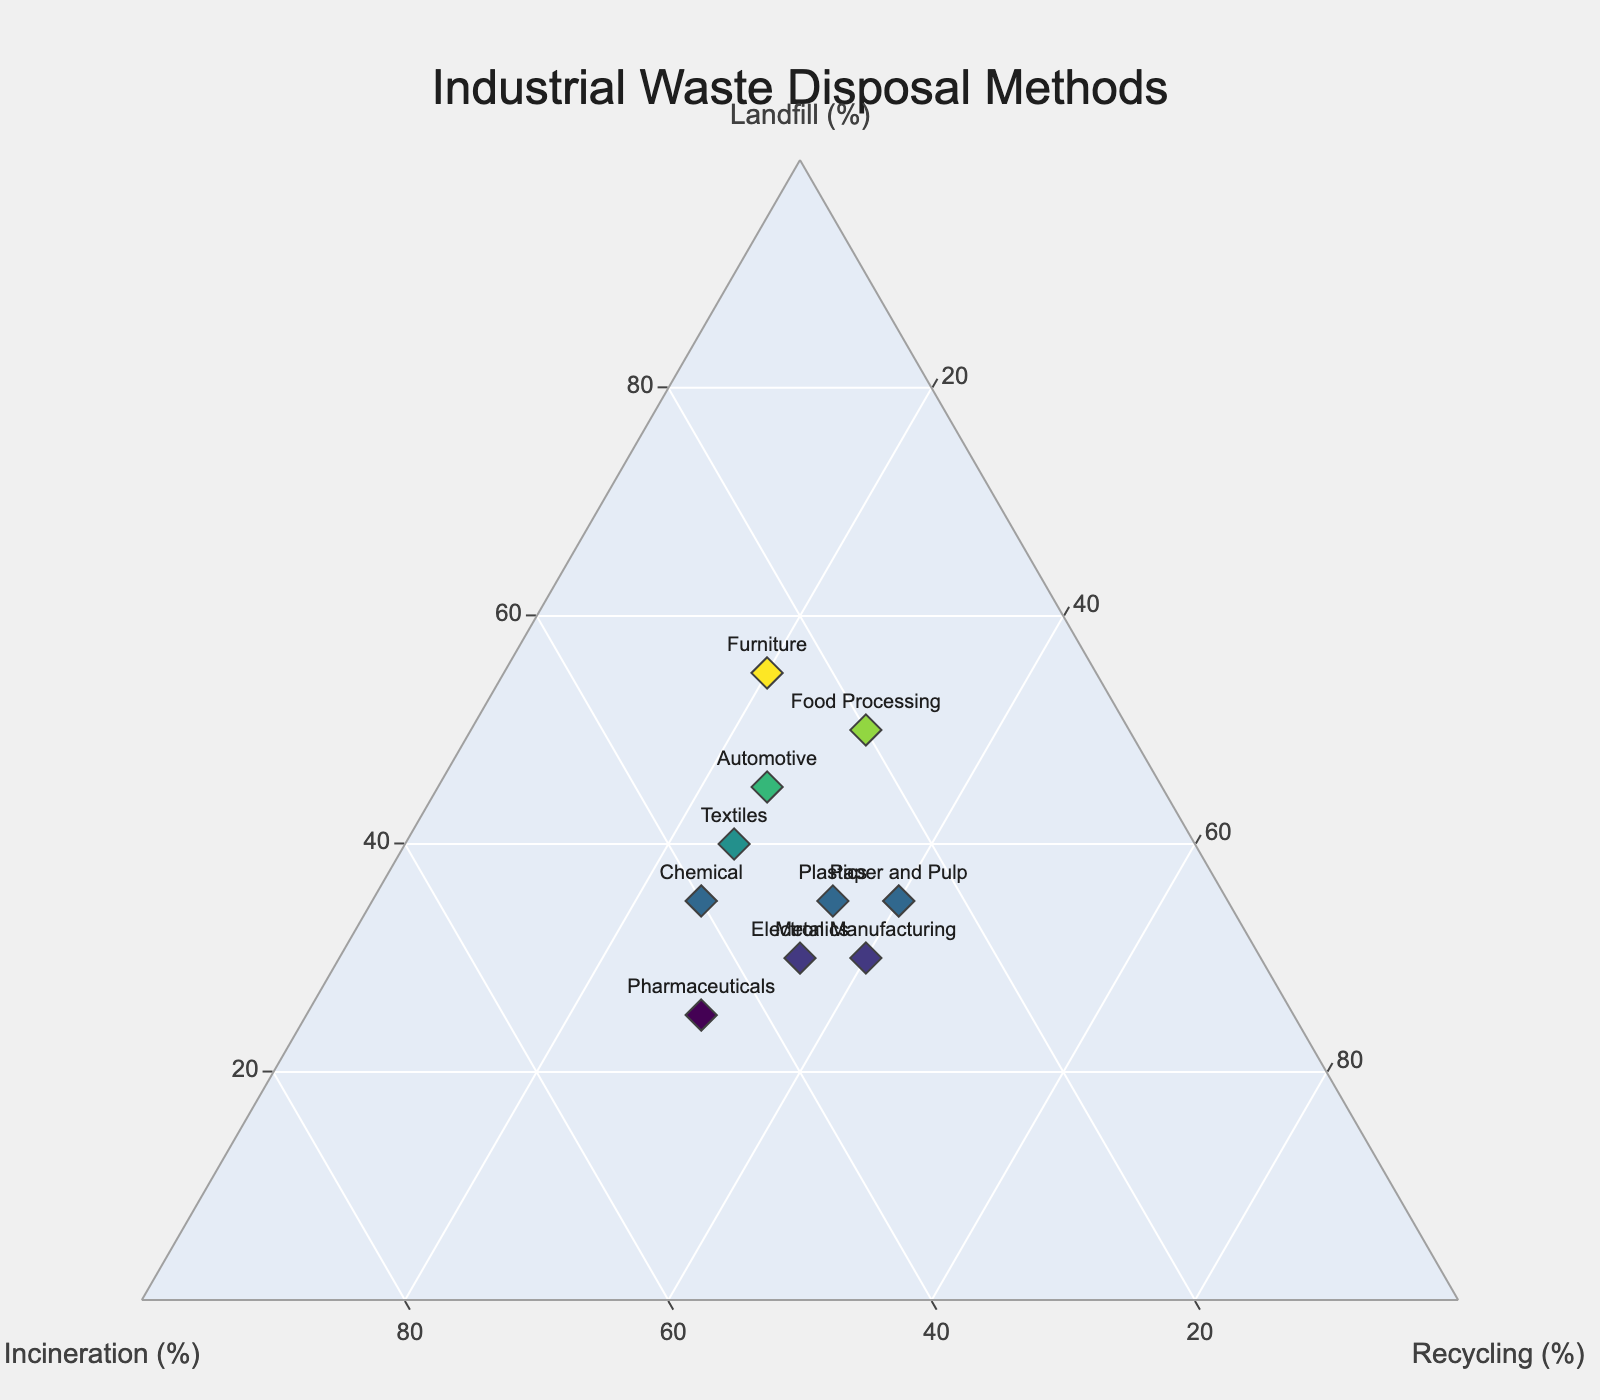What is the title of the ternary plot? The title is usually displayed at the top of the plot. In this case, it is visible in the layout customization section of the code.
Answer: Industrial Waste Disposal Methods How many manufacturing sectors are represented in the plot? Each dot on the plot represents one manufacturing sector. By counting the number of unique industries listed in the data, we find there are 10 sectors.
Answer: 10 What is the average percentage of landfill across all industries? First, sum the landfill percentages for all industries: 45 + 30 + 40 + 35 + 50 + 25 + 35 + 30 + 35 + 55 = 380. Next, divide by the number of industries, which is 10: 380 / 10 = 38.
Answer: 38 What is the median percentage of incineration across all industries? List the incineration percentages in ascending order: 20, 25, 25, 30, 30, 30, 35, 35, 40, 45. Since there are 10 values, the median is the average of the 5th and 6th values: (30 + 30) / 2 = 30.
Answer: 30 Which industry has the highest percentage of landfill? By checking the landfill percentages for all data points, we find that the Furniture industry has the highest percentage at 55%.
Answer: Furniture Does any industry have an equal percentage of incineration and recycling? We need to compare the incineration and recycling percentages for each industry. The Electronics industry has 35% for both.
Answer: Electronics Which industry is closest to having equal percentages of landfill, incineration, and recycling? The industry closest to the center of the ternary plot where all three axes are equal represents equal percentages. The Electronics industry with (30, 35, 35) is the closest to equal percentages.
Answer: Electronics Which industry relies most on recycling for waste disposal? The industry with the highest recycling percentage is the one nearest to the recycling corner of the plot. The Metal Manufacturing industry has the highest recycling percentage at 40%.
Answer: Metal Manufacturing 